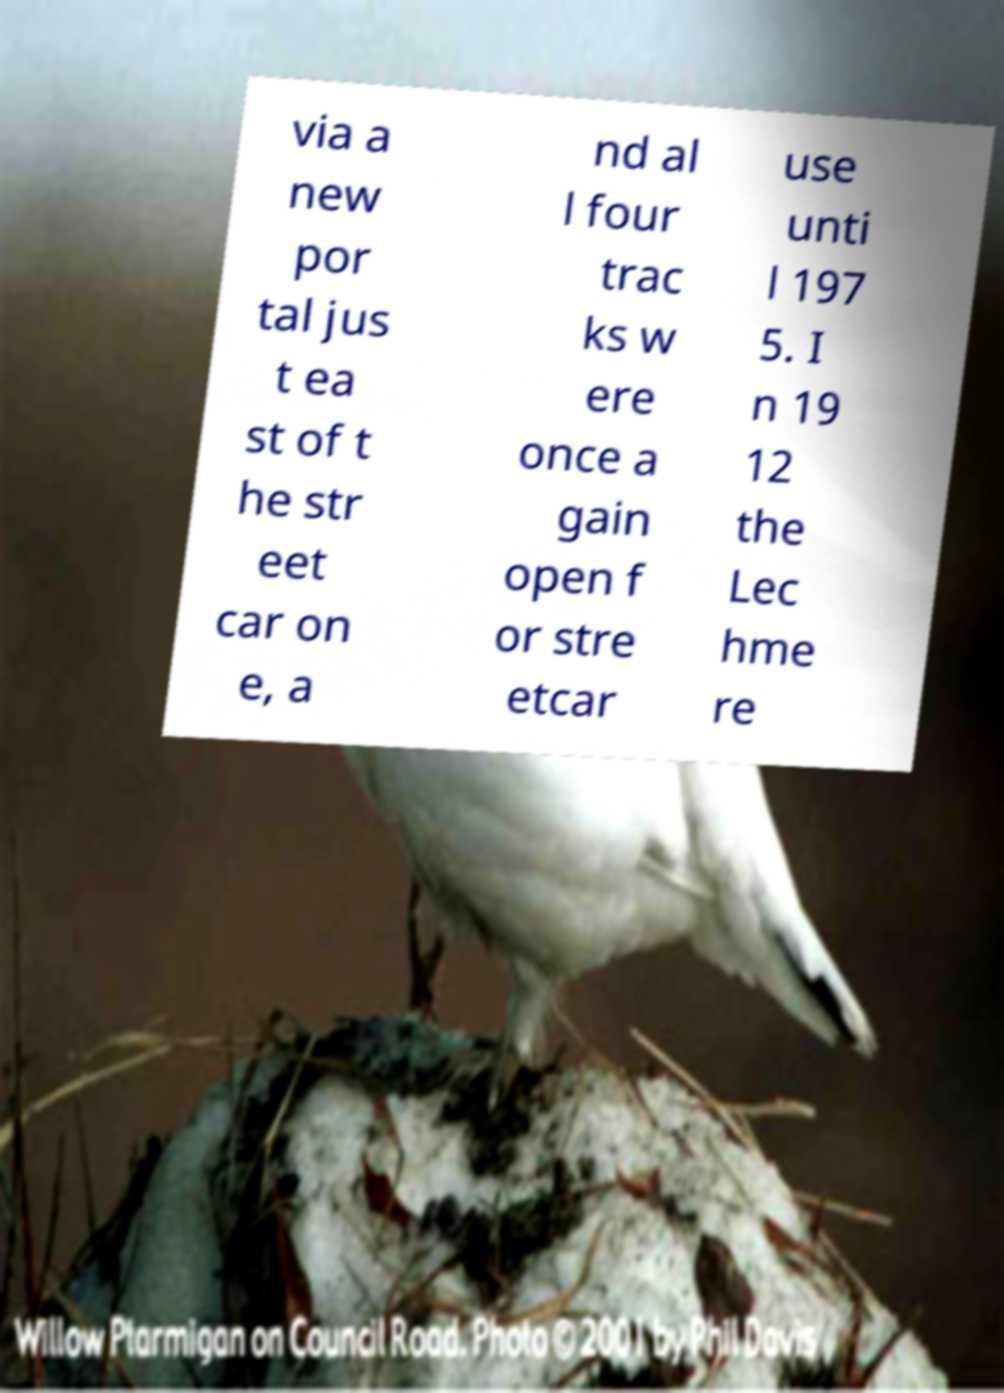Please read and relay the text visible in this image. What does it say? via a new por tal jus t ea st of t he str eet car on e, a nd al l four trac ks w ere once a gain open f or stre etcar use unti l 197 5. I n 19 12 the Lec hme re 